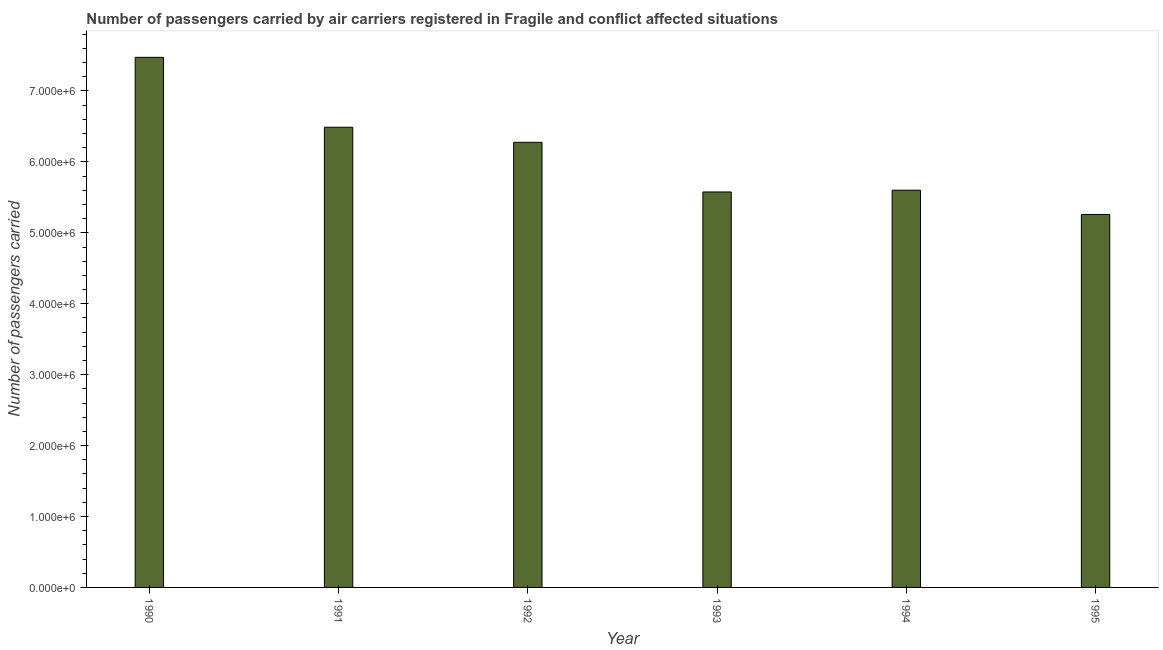What is the title of the graph?
Your answer should be very brief. Number of passengers carried by air carriers registered in Fragile and conflict affected situations. What is the label or title of the Y-axis?
Offer a very short reply. Number of passengers carried. What is the number of passengers carried in 1993?
Your answer should be very brief. 5.58e+06. Across all years, what is the maximum number of passengers carried?
Offer a terse response. 7.47e+06. Across all years, what is the minimum number of passengers carried?
Your answer should be very brief. 5.26e+06. What is the sum of the number of passengers carried?
Make the answer very short. 3.67e+07. What is the difference between the number of passengers carried in 1994 and 1995?
Keep it short and to the point. 3.42e+05. What is the average number of passengers carried per year?
Provide a short and direct response. 6.11e+06. What is the median number of passengers carried?
Your answer should be compact. 5.94e+06. In how many years, is the number of passengers carried greater than 7000000 ?
Provide a short and direct response. 1. What is the ratio of the number of passengers carried in 1990 to that in 1991?
Offer a very short reply. 1.15. Is the number of passengers carried in 1994 less than that in 1995?
Make the answer very short. No. Is the difference between the number of passengers carried in 1991 and 1995 greater than the difference between any two years?
Provide a short and direct response. No. What is the difference between the highest and the second highest number of passengers carried?
Offer a terse response. 9.86e+05. What is the difference between the highest and the lowest number of passengers carried?
Provide a short and direct response. 2.22e+06. In how many years, is the number of passengers carried greater than the average number of passengers carried taken over all years?
Provide a short and direct response. 3. How many bars are there?
Keep it short and to the point. 6. Are all the bars in the graph horizontal?
Provide a succinct answer. No. What is the Number of passengers carried in 1990?
Your answer should be very brief. 7.47e+06. What is the Number of passengers carried of 1991?
Make the answer very short. 6.49e+06. What is the Number of passengers carried of 1992?
Offer a terse response. 6.28e+06. What is the Number of passengers carried of 1993?
Ensure brevity in your answer.  5.58e+06. What is the Number of passengers carried of 1994?
Make the answer very short. 5.60e+06. What is the Number of passengers carried in 1995?
Make the answer very short. 5.26e+06. What is the difference between the Number of passengers carried in 1990 and 1991?
Your response must be concise. 9.86e+05. What is the difference between the Number of passengers carried in 1990 and 1992?
Offer a very short reply. 1.20e+06. What is the difference between the Number of passengers carried in 1990 and 1993?
Keep it short and to the point. 1.90e+06. What is the difference between the Number of passengers carried in 1990 and 1994?
Make the answer very short. 1.87e+06. What is the difference between the Number of passengers carried in 1990 and 1995?
Offer a very short reply. 2.22e+06. What is the difference between the Number of passengers carried in 1991 and 1992?
Provide a short and direct response. 2.13e+05. What is the difference between the Number of passengers carried in 1991 and 1993?
Ensure brevity in your answer.  9.13e+05. What is the difference between the Number of passengers carried in 1991 and 1994?
Keep it short and to the point. 8.88e+05. What is the difference between the Number of passengers carried in 1991 and 1995?
Make the answer very short. 1.23e+06. What is the difference between the Number of passengers carried in 1992 and 1994?
Keep it short and to the point. 6.75e+05. What is the difference between the Number of passengers carried in 1992 and 1995?
Keep it short and to the point. 1.02e+06. What is the difference between the Number of passengers carried in 1993 and 1994?
Keep it short and to the point. -2.49e+04. What is the difference between the Number of passengers carried in 1993 and 1995?
Your response must be concise. 3.17e+05. What is the difference between the Number of passengers carried in 1994 and 1995?
Ensure brevity in your answer.  3.42e+05. What is the ratio of the Number of passengers carried in 1990 to that in 1991?
Make the answer very short. 1.15. What is the ratio of the Number of passengers carried in 1990 to that in 1992?
Offer a very short reply. 1.19. What is the ratio of the Number of passengers carried in 1990 to that in 1993?
Your answer should be compact. 1.34. What is the ratio of the Number of passengers carried in 1990 to that in 1994?
Your answer should be very brief. 1.33. What is the ratio of the Number of passengers carried in 1990 to that in 1995?
Ensure brevity in your answer.  1.42. What is the ratio of the Number of passengers carried in 1991 to that in 1992?
Your response must be concise. 1.03. What is the ratio of the Number of passengers carried in 1991 to that in 1993?
Offer a terse response. 1.16. What is the ratio of the Number of passengers carried in 1991 to that in 1994?
Provide a succinct answer. 1.16. What is the ratio of the Number of passengers carried in 1991 to that in 1995?
Your response must be concise. 1.23. What is the ratio of the Number of passengers carried in 1992 to that in 1993?
Offer a terse response. 1.13. What is the ratio of the Number of passengers carried in 1992 to that in 1994?
Provide a short and direct response. 1.12. What is the ratio of the Number of passengers carried in 1992 to that in 1995?
Ensure brevity in your answer.  1.19. What is the ratio of the Number of passengers carried in 1993 to that in 1994?
Give a very brief answer. 1. What is the ratio of the Number of passengers carried in 1993 to that in 1995?
Make the answer very short. 1.06. What is the ratio of the Number of passengers carried in 1994 to that in 1995?
Your response must be concise. 1.06. 